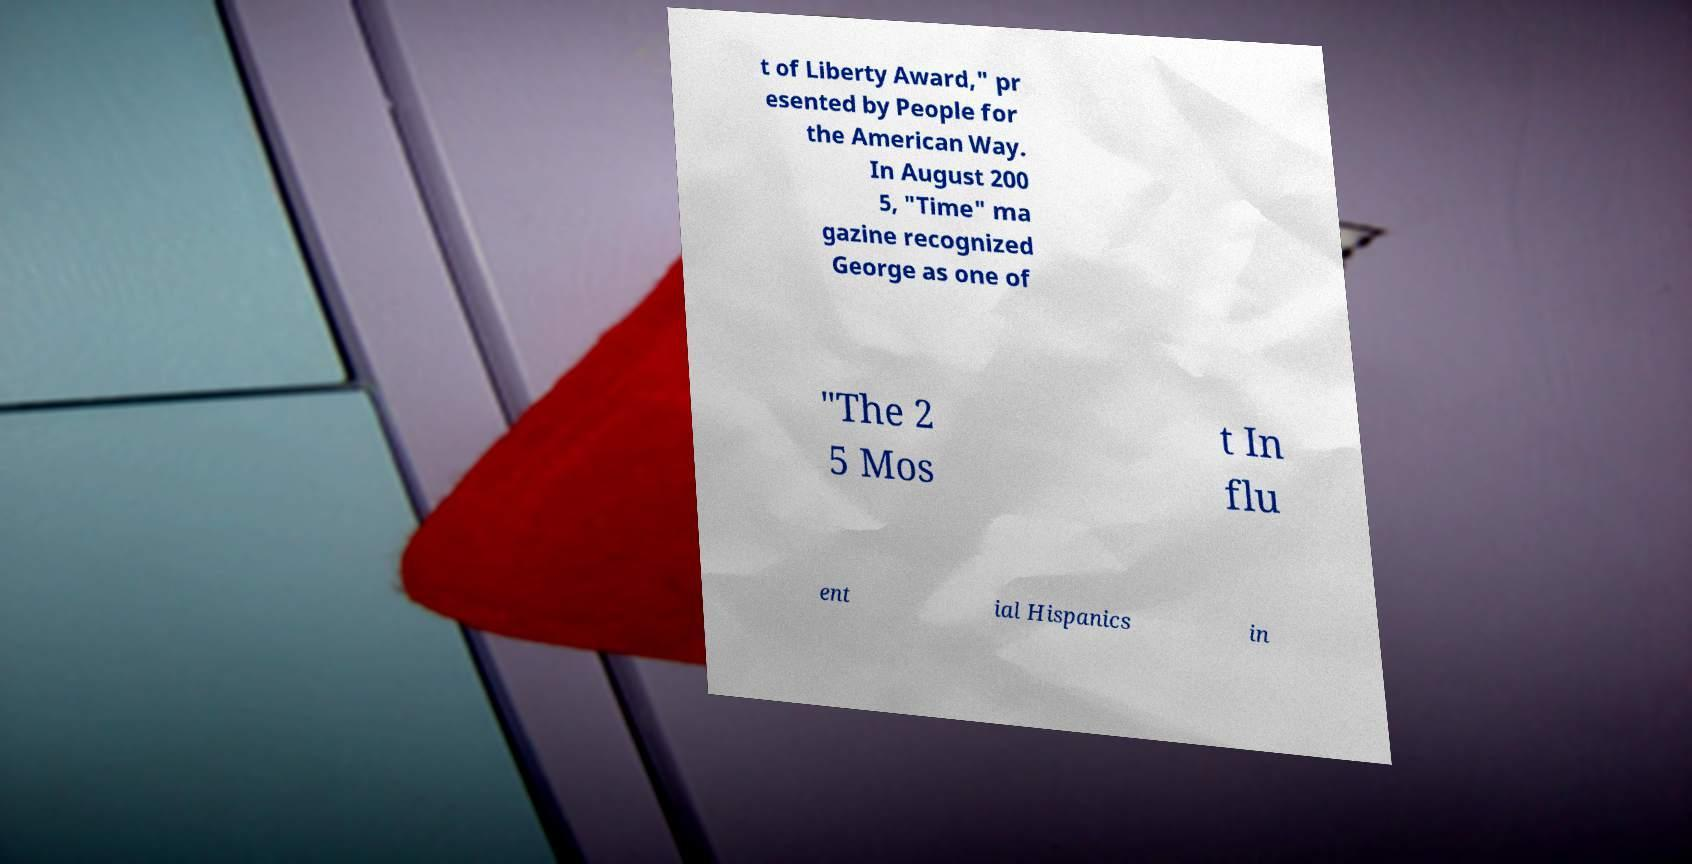Can you accurately transcribe the text from the provided image for me? t of Liberty Award," pr esented by People for the American Way. In August 200 5, "Time" ma gazine recognized George as one of "The 2 5 Mos t In flu ent ial Hispanics in 